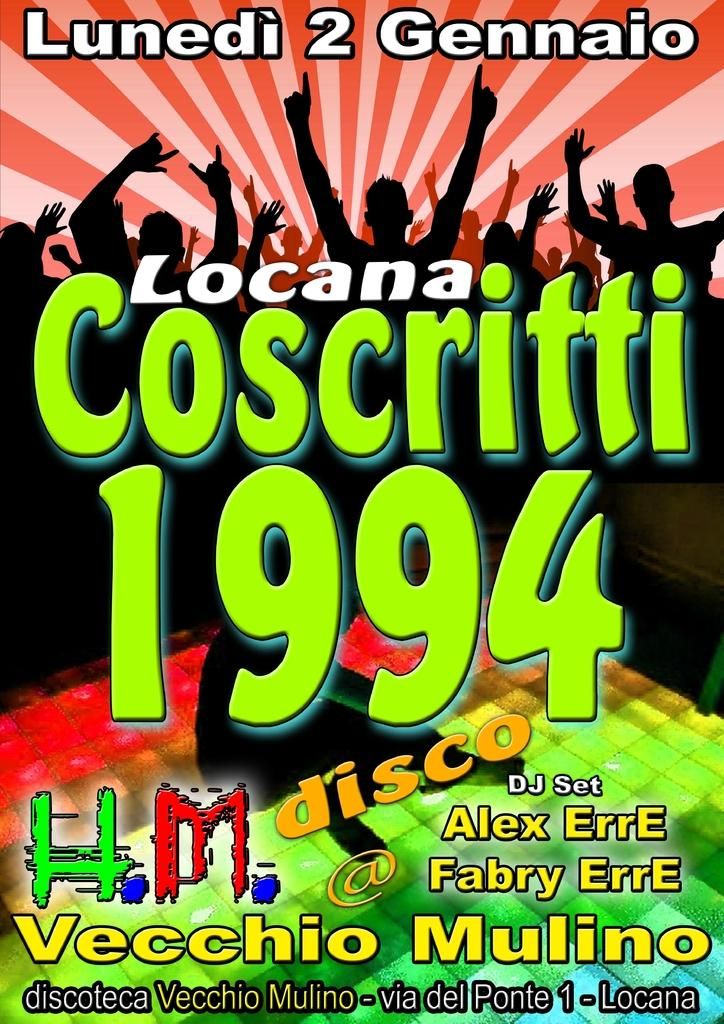<image>
Create a compact narrative representing the image presented. A poster of Lundei 2 Gennaio Locana Coscritti 1994. 